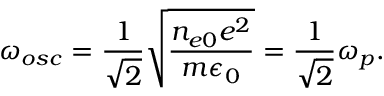Convert formula to latex. <formula><loc_0><loc_0><loc_500><loc_500>\omega _ { o s c } = \frac { 1 } { \sqrt { 2 } } \sqrt { \frac { n _ { e 0 } e ^ { 2 } } { m \epsilon _ { 0 } } } = \frac { 1 } { \sqrt { 2 } } \omega _ { p } .</formula> 